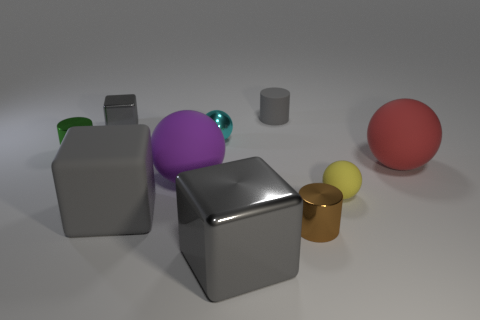What number of yellow objects are either large rubber things or rubber blocks?
Your answer should be compact. 0. What number of red things are the same size as the red rubber ball?
Your response must be concise. 0. What is the color of the small metal thing that is both on the right side of the large purple thing and behind the big red ball?
Your response must be concise. Cyan. Are there more green shiny things that are behind the gray rubber cylinder than large purple metallic cylinders?
Keep it short and to the point. No. Are any small brown matte spheres visible?
Your response must be concise. No. Is the tiny block the same color as the matte cylinder?
Keep it short and to the point. Yes. What number of tiny objects are brown rubber blocks or cyan metallic spheres?
Provide a short and direct response. 1. Are there any other things of the same color as the shiny ball?
Keep it short and to the point. No. The small gray object that is the same material as the cyan object is what shape?
Offer a terse response. Cube. What size is the cylinder behind the green cylinder?
Ensure brevity in your answer.  Small. 